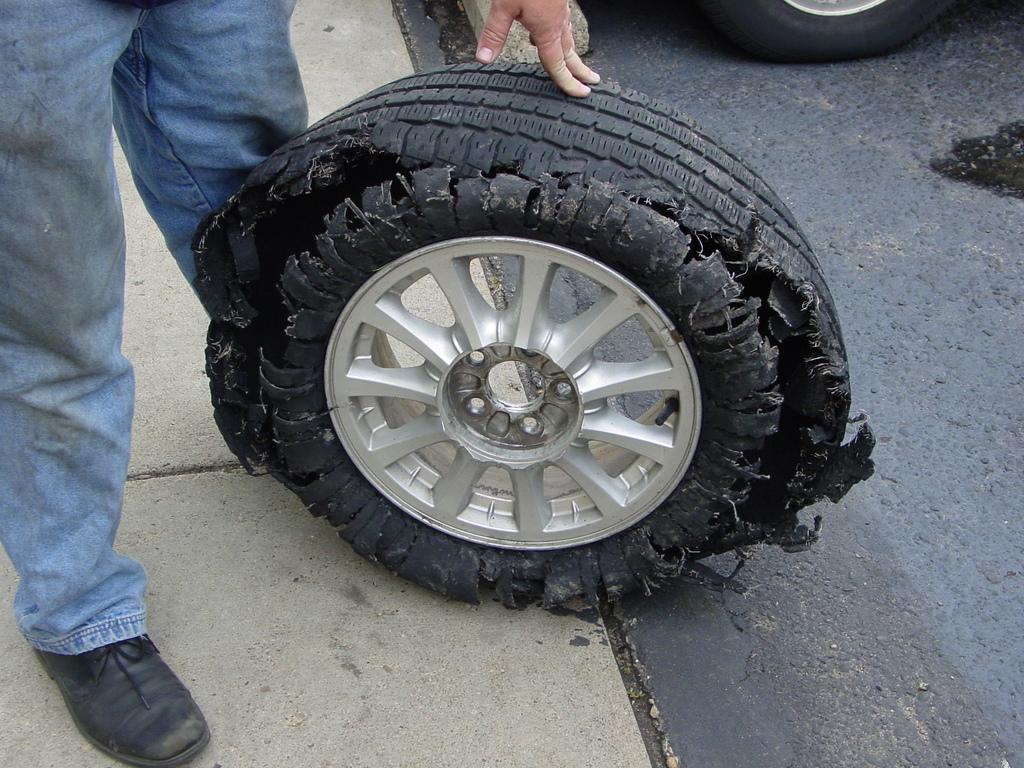How would you summarize this image in a sentence or two? In this picture, we can see a person, tired of a vehicles, and the ground. 